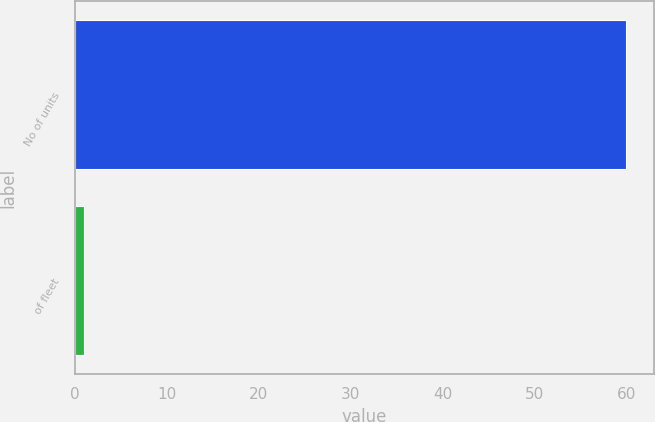Convert chart to OTSL. <chart><loc_0><loc_0><loc_500><loc_500><bar_chart><fcel>No of units<fcel>of fleet<nl><fcel>60<fcel>1<nl></chart> 